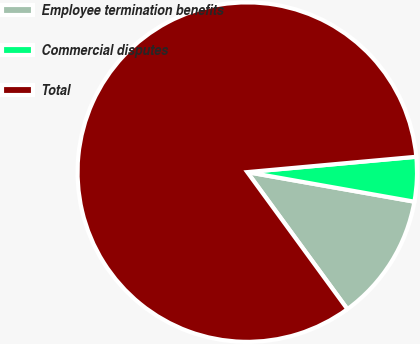<chart> <loc_0><loc_0><loc_500><loc_500><pie_chart><fcel>Employee termination benefits<fcel>Commercial disputes<fcel>Total<nl><fcel>12.17%<fcel>4.23%<fcel>83.6%<nl></chart> 